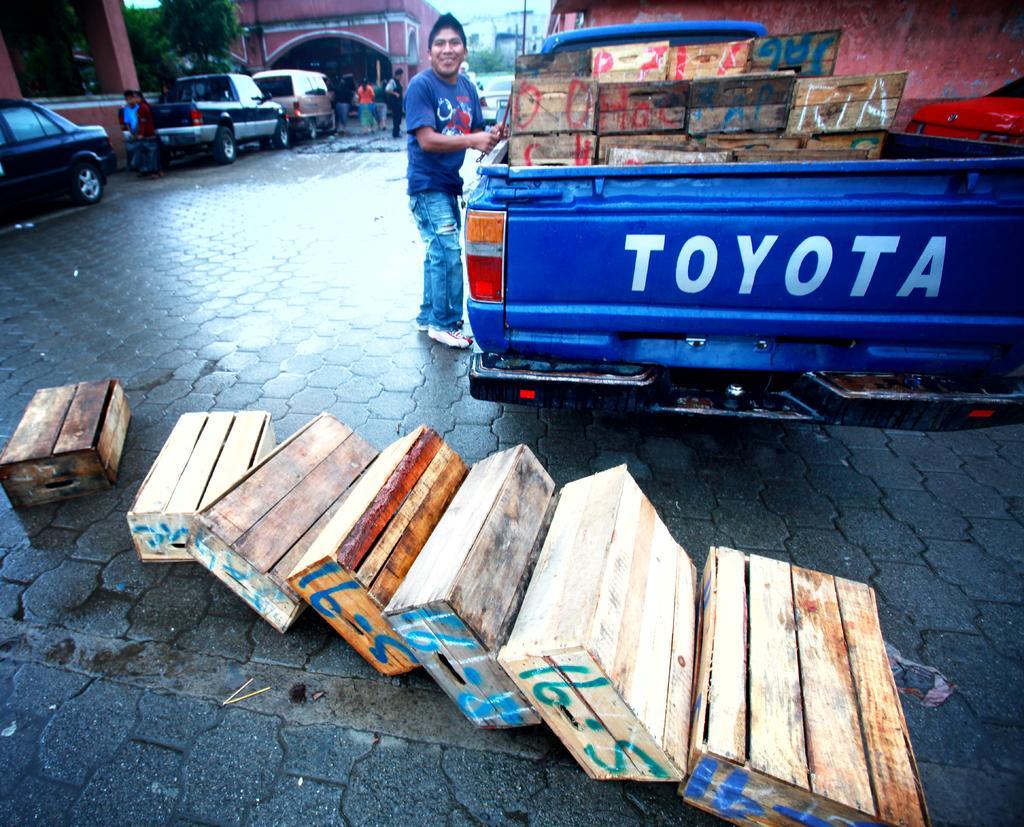In one or two sentences, can you explain what this image depicts? In this image, we can see vehicles, wooden boxes, buildings, trees, people and we can see a pole. At the bottom, there is a road. 